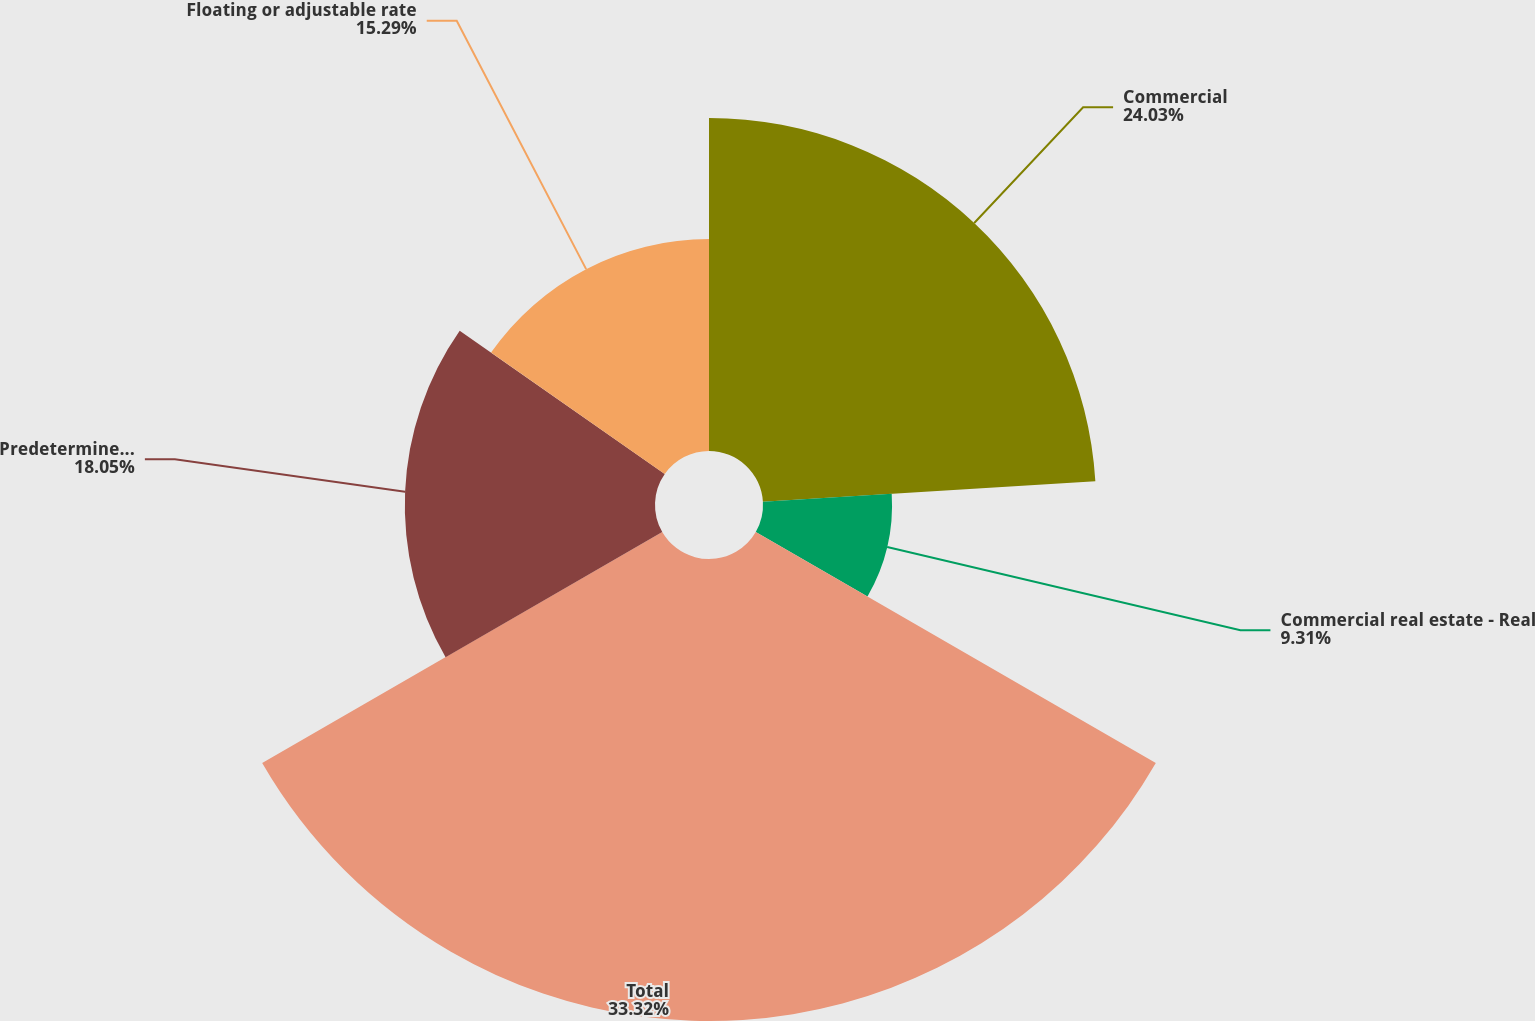Convert chart. <chart><loc_0><loc_0><loc_500><loc_500><pie_chart><fcel>Commercial<fcel>Commercial real estate - Real<fcel>Total<fcel>Predetermined rate<fcel>Floating or adjustable rate<nl><fcel>24.03%<fcel>9.31%<fcel>33.33%<fcel>18.05%<fcel>15.29%<nl></chart> 